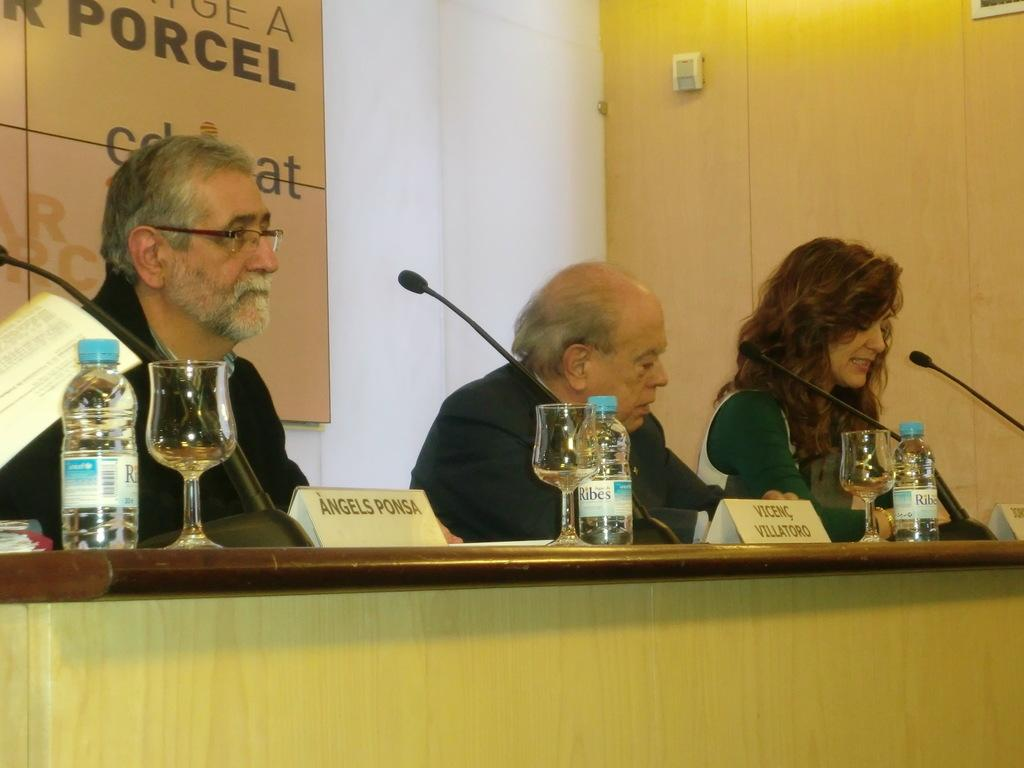<image>
Render a clear and concise summary of the photo. Angels Ponsa sits before a microphone wearing glasses and looking outward into the room. 